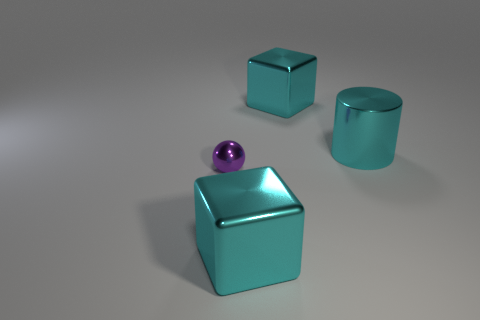Do the small object and the big shiny cube behind the big cylinder have the same color?
Provide a short and direct response. No. How many other metallic cylinders are the same color as the big metal cylinder?
Your answer should be very brief. 0. How big is the metal block right of the cyan cube that is in front of the tiny metal thing?
Give a very brief answer. Large. What number of objects are cyan metal blocks that are in front of the purple ball or large metal cylinders?
Your response must be concise. 2. Are there any cyan things of the same size as the purple metallic thing?
Ensure brevity in your answer.  No. Is there a big metallic cylinder in front of the big metallic cylinder to the right of the sphere?
Keep it short and to the point. No. How many cylinders are either tiny purple metal things or cyan things?
Your response must be concise. 1. Is there another purple object of the same shape as the purple shiny object?
Offer a terse response. No. What is the shape of the purple metallic thing?
Offer a terse response. Sphere. What number of objects are large cyan metal cylinders or purple objects?
Ensure brevity in your answer.  2. 